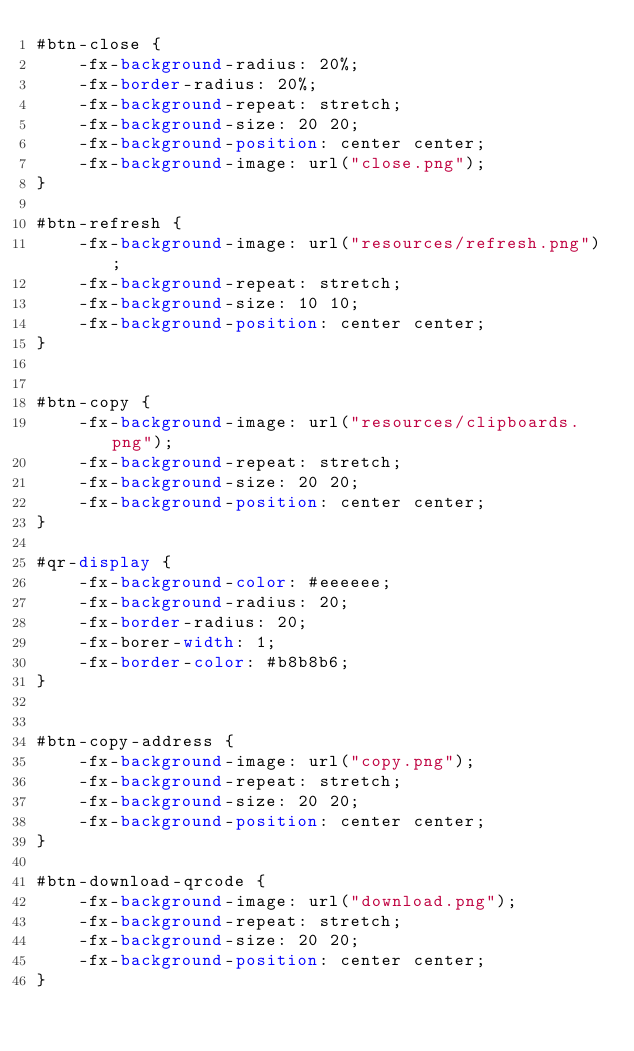<code> <loc_0><loc_0><loc_500><loc_500><_CSS_>#btn-close {
    -fx-background-radius: 20%;
    -fx-border-radius: 20%;
    -fx-background-repeat: stretch;
    -fx-background-size: 20 20;
    -fx-background-position: center center;
    -fx-background-image: url("close.png");
}

#btn-refresh {
    -fx-background-image: url("resources/refresh.png");
    -fx-background-repeat: stretch;
    -fx-background-size: 10 10;
    -fx-background-position: center center;
}


#btn-copy {
    -fx-background-image: url("resources/clipboards.png");
    -fx-background-repeat: stretch;
    -fx-background-size: 20 20;
    -fx-background-position: center center;
}

#qr-display {
    -fx-background-color: #eeeeee;
    -fx-background-radius: 20;
    -fx-border-radius: 20;
    -fx-borer-width: 1;
    -fx-border-color: #b8b8b6;
}


#btn-copy-address {
    -fx-background-image: url("copy.png");
    -fx-background-repeat: stretch;
    -fx-background-size: 20 20;
    -fx-background-position: center center;
}

#btn-download-qrcode {
    -fx-background-image: url("download.png");
    -fx-background-repeat: stretch;
    -fx-background-size: 20 20;
    -fx-background-position: center center;
}</code> 